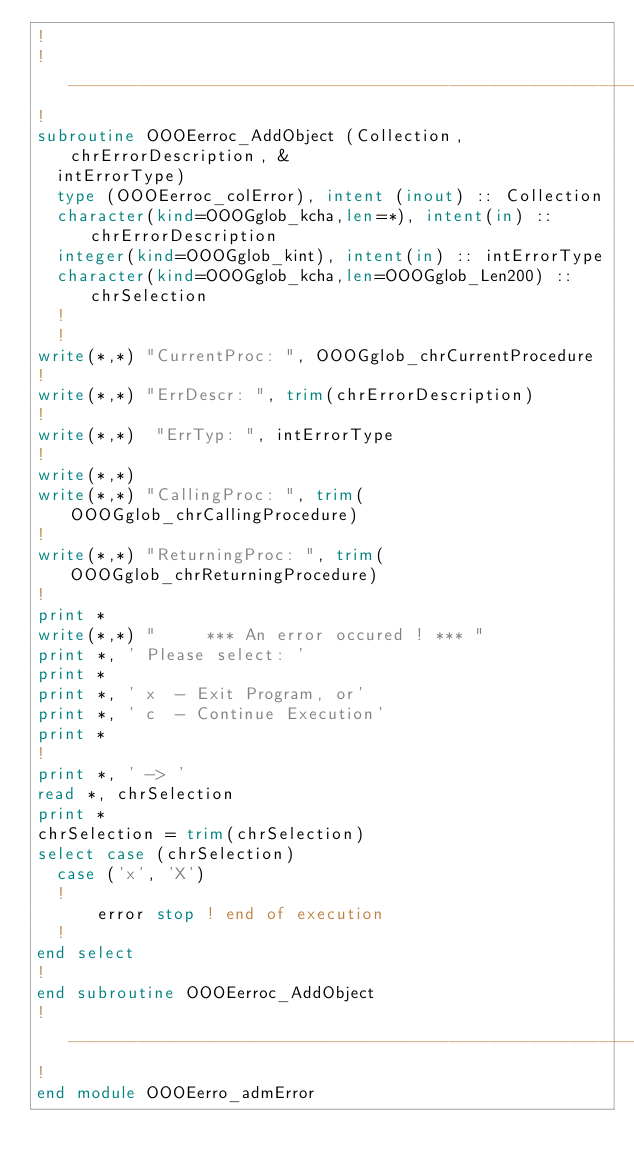Convert code to text. <code><loc_0><loc_0><loc_500><loc_500><_FORTRAN_>!
!___________________________________________________________
!
subroutine OOOEerroc_AddObject (Collection, chrErrorDescription, &
  intErrorType)
  type (OOOEerroc_colError), intent (inout) :: Collection
  character(kind=OOOGglob_kcha,len=*), intent(in) :: chrErrorDescription
  integer(kind=OOOGglob_kint), intent(in) :: intErrorType
  character(kind=OOOGglob_kcha,len=OOOGglob_Len200) :: chrSelection
  !
  !
write(*,*) "CurrentProc: ", OOOGglob_chrCurrentProcedure
!
write(*,*) "ErrDescr: ", trim(chrErrorDescription)
!
write(*,*)  "ErrTyp: ", intErrorType
!
write(*,*)
write(*,*) "CallingProc: ", trim(OOOGglob_chrCallingProcedure)
!
write(*,*) "ReturningProc: ", trim(OOOGglob_chrReturningProcedure)
!
print *
write(*,*) "     *** An error occured ! *** "
print *, ' Please select: '
print *
print *, ' x  - Exit Program, or'
print *, ' c  - Continue Execution'
print *
!
print *, ' -> '
read *, chrSelection
print *
chrSelection = trim(chrSelection)
select case (chrSelection)
  case ('x', 'X')
  !
      error stop ! end of execution
  !
end select
!
end subroutine OOOEerroc_AddObject
!___________________________________________________________
!
end module OOOEerro_admError
</code> 